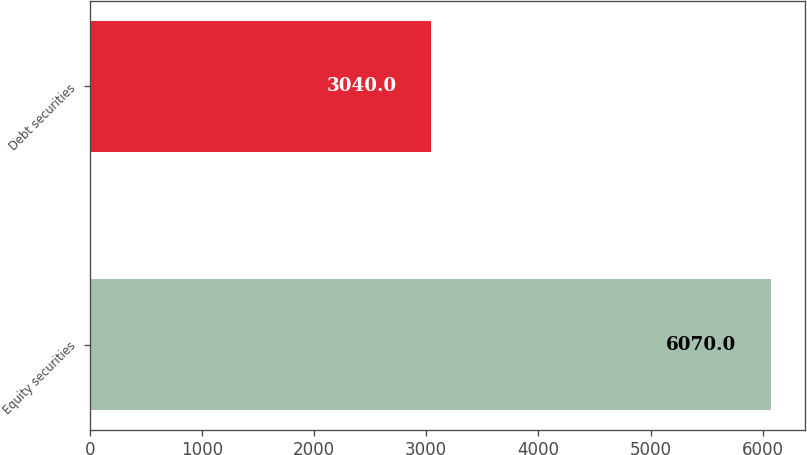Convert chart. <chart><loc_0><loc_0><loc_500><loc_500><bar_chart><fcel>Equity securities<fcel>Debt securities<nl><fcel>6070<fcel>3040<nl></chart> 